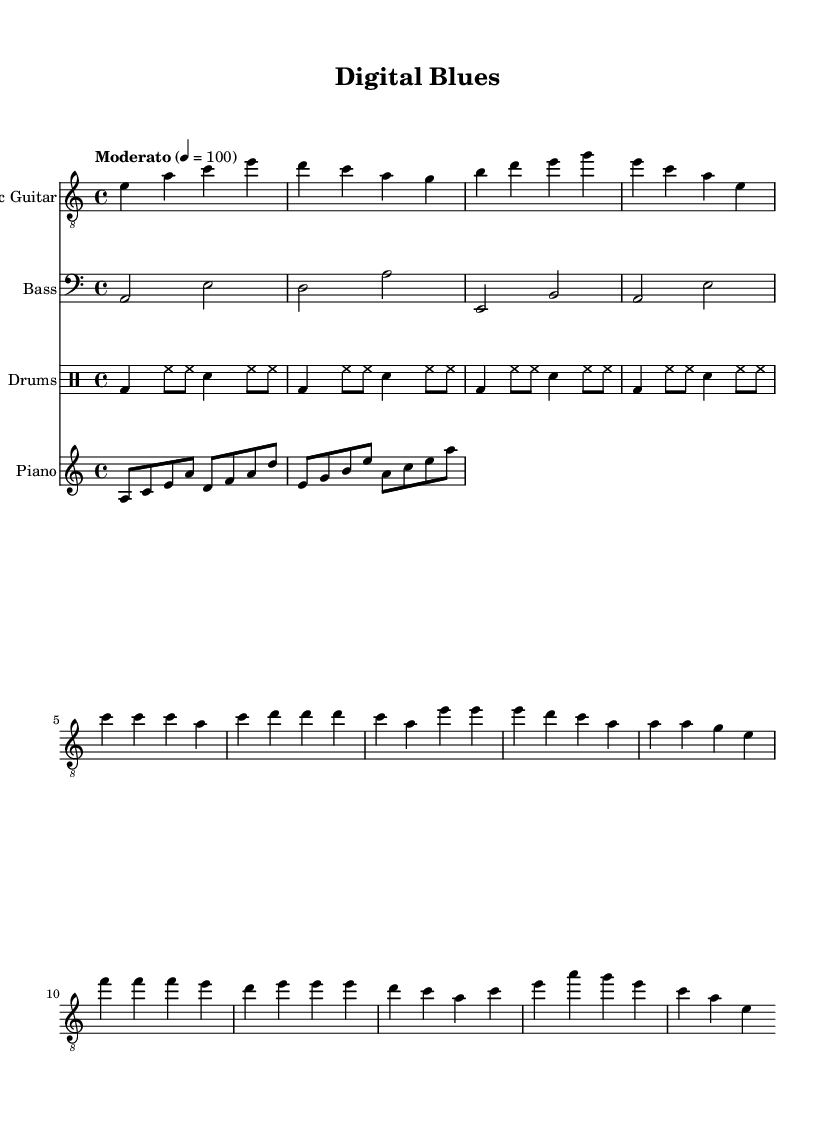What is the key signature of this music? The key signature is A minor, which has no sharps or flats. It can be identified by the natural sign indicating A as the tonic note.
Answer: A minor What is the time signature of this music? The time signature is 4/4, which means there are four beats in every measure, and the quarter note gets one beat. This can be seen at the beginning of the sheet music.
Answer: 4/4 What is the tempo marking of this piece? The tempo marking is "Moderato" with a metronome marking of 100 beats per minute, indicating a moderate speed. This is stated at the beginning of the score.
Answer: Moderato How many measures are in the electric guitar part? The electric guitar part consists of 12 measures, as counted from the beginning of the music section to the end of the part notated.
Answer: 12 What is the role of the bass guitar in this piece? The bass guitar provides rhythmic support and low harmonic foundation, typically outlining the chord progressions indicated by the electric guitar, which can be analyzed by comparing the notes played in both parts.
Answer: Rhythmic support Is this music primarily composed for an ensemble or solo performance? This music is composed for an ensemble as it includes multiple instruments: electric guitar, bass guitar, drums, and piano, indicating a band setting rather than a solo performance.
Answer: Ensemble Which genre does this piece belong to and what makes it characteristic of that genre? This piece belongs to the Blues genre, characterized by its unique structure, 12-bar form, and emotional expression, as well as the specific use of instruments like electric guitar and the blues scale, evident in the melody.
Answer: Blues 